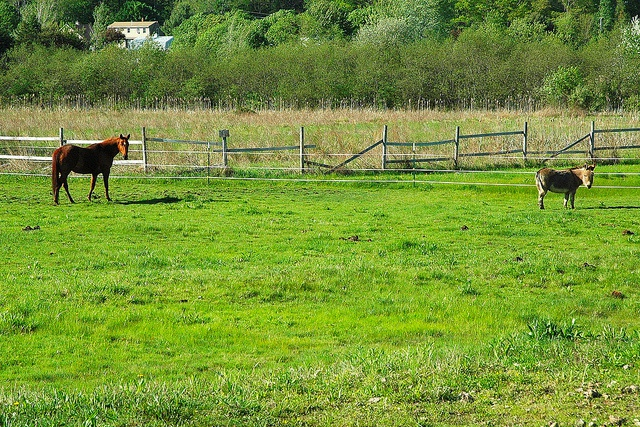Describe the objects in this image and their specific colors. I can see horse in darkgreen, black, maroon, olive, and brown tones and horse in darkgreen, black, olive, and khaki tones in this image. 